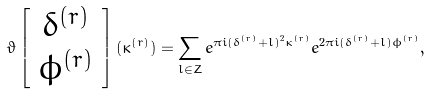<formula> <loc_0><loc_0><loc_500><loc_500>\vartheta \left [ \begin{array} { c } \delta ^ { ( r ) } \\ \phi ^ { ( r ) } \end{array} \right ] ( \kappa ^ { ( r ) } ) = \sum _ { l \in Z } e ^ { \pi i ( \delta ^ { ( r ) } + l ) ^ { 2 } \kappa ^ { ( r ) } } e ^ { 2 \pi i ( \delta ^ { ( r ) } + l ) \phi ^ { ( r ) } } ,</formula> 